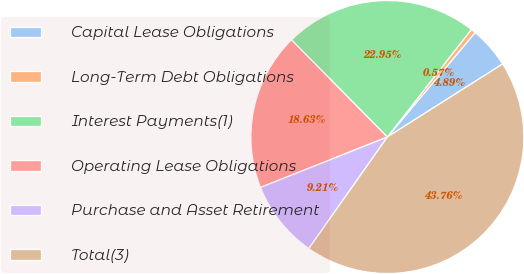<chart> <loc_0><loc_0><loc_500><loc_500><pie_chart><fcel>Capital Lease Obligations<fcel>Long-Term Debt Obligations<fcel>Interest Payments(1)<fcel>Operating Lease Obligations<fcel>Purchase and Asset Retirement<fcel>Total(3)<nl><fcel>4.89%<fcel>0.57%<fcel>22.95%<fcel>18.63%<fcel>9.21%<fcel>43.76%<nl></chart> 